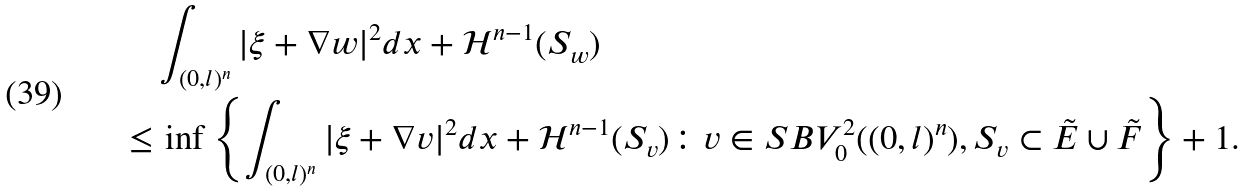<formula> <loc_0><loc_0><loc_500><loc_500>& \int _ { ( 0 , l ) ^ { n } } | \xi + \nabla w | ^ { 2 } d x + \mathcal { H } ^ { n - 1 } ( S _ { w } ) \\ \leq & \, \inf \left \{ \int _ { ( 0 , l ) ^ { n } } | \xi + \nabla v | ^ { 2 } d x + \mathcal { H } ^ { n - 1 } ( S _ { v } ) \colon v \in S B V ^ { 2 } _ { 0 } ( ( 0 , l ) ^ { n } ) , S _ { v } \subset \tilde { E } \cup \tilde { F } \right \} + 1 .</formula> 